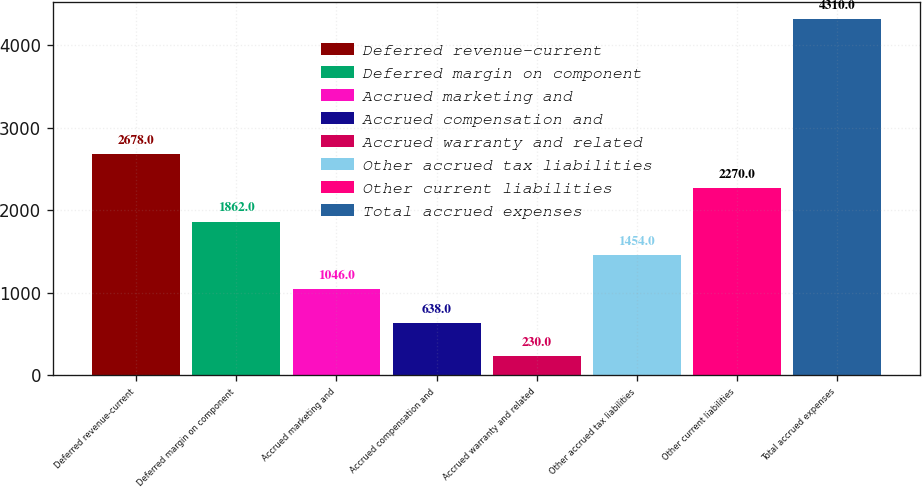Convert chart to OTSL. <chart><loc_0><loc_0><loc_500><loc_500><bar_chart><fcel>Deferred revenue-current<fcel>Deferred margin on component<fcel>Accrued marketing and<fcel>Accrued compensation and<fcel>Accrued warranty and related<fcel>Other accrued tax liabilities<fcel>Other current liabilities<fcel>Total accrued expenses<nl><fcel>2678<fcel>1862<fcel>1046<fcel>638<fcel>230<fcel>1454<fcel>2270<fcel>4310<nl></chart> 